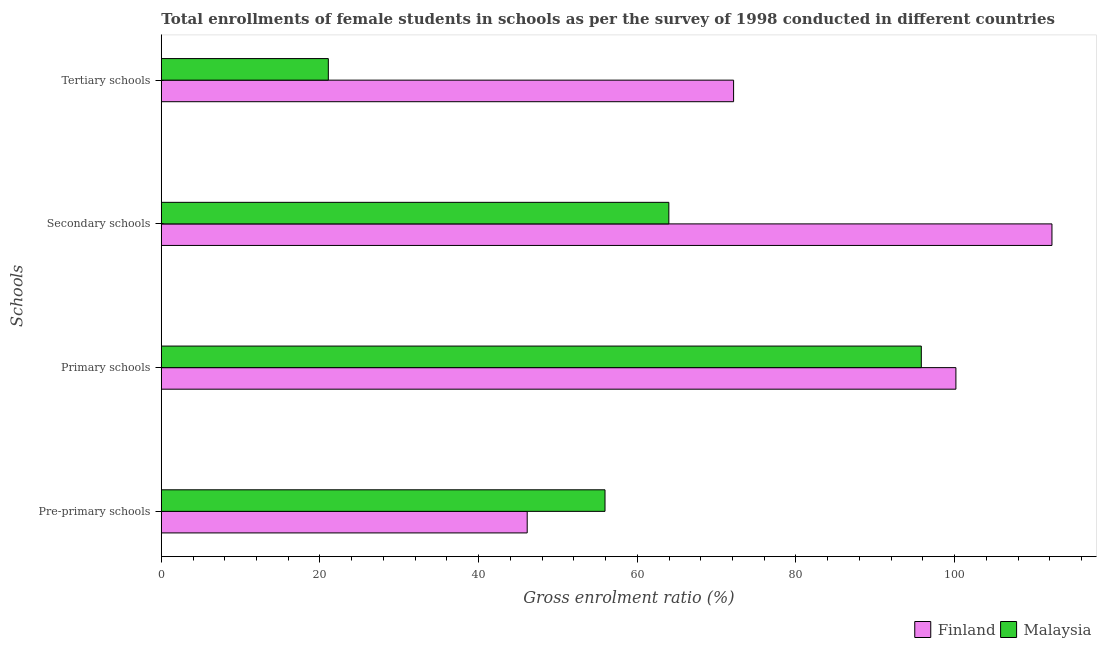How many different coloured bars are there?
Provide a short and direct response. 2. How many bars are there on the 3rd tick from the bottom?
Ensure brevity in your answer.  2. What is the label of the 1st group of bars from the top?
Make the answer very short. Tertiary schools. What is the gross enrolment ratio(female) in primary schools in Malaysia?
Your answer should be very brief. 95.8. Across all countries, what is the maximum gross enrolment ratio(female) in tertiary schools?
Make the answer very short. 72.14. Across all countries, what is the minimum gross enrolment ratio(female) in secondary schools?
Keep it short and to the point. 63.98. In which country was the gross enrolment ratio(female) in secondary schools maximum?
Make the answer very short. Finland. In which country was the gross enrolment ratio(female) in tertiary schools minimum?
Keep it short and to the point. Malaysia. What is the total gross enrolment ratio(female) in pre-primary schools in the graph?
Your answer should be compact. 102.05. What is the difference between the gross enrolment ratio(female) in tertiary schools in Finland and that in Malaysia?
Your answer should be very brief. 51.09. What is the difference between the gross enrolment ratio(female) in pre-primary schools in Finland and the gross enrolment ratio(female) in tertiary schools in Malaysia?
Your response must be concise. 25.07. What is the average gross enrolment ratio(female) in secondary schools per country?
Provide a succinct answer. 88.12. What is the difference between the gross enrolment ratio(female) in primary schools and gross enrolment ratio(female) in secondary schools in Finland?
Offer a terse response. -12.11. What is the ratio of the gross enrolment ratio(female) in tertiary schools in Malaysia to that in Finland?
Give a very brief answer. 0.29. Is the gross enrolment ratio(female) in secondary schools in Finland less than that in Malaysia?
Provide a succinct answer. No. Is the difference between the gross enrolment ratio(female) in pre-primary schools in Malaysia and Finland greater than the difference between the gross enrolment ratio(female) in primary schools in Malaysia and Finland?
Your response must be concise. Yes. What is the difference between the highest and the second highest gross enrolment ratio(female) in pre-primary schools?
Provide a short and direct response. 9.81. What is the difference between the highest and the lowest gross enrolment ratio(female) in secondary schools?
Your answer should be compact. 48.29. In how many countries, is the gross enrolment ratio(female) in tertiary schools greater than the average gross enrolment ratio(female) in tertiary schools taken over all countries?
Offer a very short reply. 1. What does the 2nd bar from the top in Secondary schools represents?
Offer a very short reply. Finland. What does the 1st bar from the bottom in Tertiary schools represents?
Your answer should be compact. Finland. Is it the case that in every country, the sum of the gross enrolment ratio(female) in pre-primary schools and gross enrolment ratio(female) in primary schools is greater than the gross enrolment ratio(female) in secondary schools?
Your response must be concise. Yes. How many bars are there?
Your answer should be compact. 8. What is the difference between two consecutive major ticks on the X-axis?
Provide a succinct answer. 20. Are the values on the major ticks of X-axis written in scientific E-notation?
Ensure brevity in your answer.  No. Where does the legend appear in the graph?
Offer a terse response. Bottom right. How many legend labels are there?
Keep it short and to the point. 2. How are the legend labels stacked?
Offer a terse response. Horizontal. What is the title of the graph?
Give a very brief answer. Total enrollments of female students in schools as per the survey of 1998 conducted in different countries. What is the label or title of the X-axis?
Your answer should be compact. Gross enrolment ratio (%). What is the label or title of the Y-axis?
Make the answer very short. Schools. What is the Gross enrolment ratio (%) of Finland in Pre-primary schools?
Provide a short and direct response. 46.12. What is the Gross enrolment ratio (%) of Malaysia in Pre-primary schools?
Your response must be concise. 55.93. What is the Gross enrolment ratio (%) of Finland in Primary schools?
Make the answer very short. 100.16. What is the Gross enrolment ratio (%) of Malaysia in Primary schools?
Your answer should be compact. 95.8. What is the Gross enrolment ratio (%) in Finland in Secondary schools?
Your response must be concise. 112.27. What is the Gross enrolment ratio (%) of Malaysia in Secondary schools?
Keep it short and to the point. 63.98. What is the Gross enrolment ratio (%) of Finland in Tertiary schools?
Keep it short and to the point. 72.14. What is the Gross enrolment ratio (%) in Malaysia in Tertiary schools?
Ensure brevity in your answer.  21.05. Across all Schools, what is the maximum Gross enrolment ratio (%) of Finland?
Offer a very short reply. 112.27. Across all Schools, what is the maximum Gross enrolment ratio (%) of Malaysia?
Provide a short and direct response. 95.8. Across all Schools, what is the minimum Gross enrolment ratio (%) in Finland?
Offer a very short reply. 46.12. Across all Schools, what is the minimum Gross enrolment ratio (%) in Malaysia?
Offer a terse response. 21.05. What is the total Gross enrolment ratio (%) in Finland in the graph?
Your response must be concise. 330.69. What is the total Gross enrolment ratio (%) in Malaysia in the graph?
Provide a short and direct response. 236.76. What is the difference between the Gross enrolment ratio (%) in Finland in Pre-primary schools and that in Primary schools?
Give a very brief answer. -54.04. What is the difference between the Gross enrolment ratio (%) in Malaysia in Pre-primary schools and that in Primary schools?
Keep it short and to the point. -39.87. What is the difference between the Gross enrolment ratio (%) of Finland in Pre-primary schools and that in Secondary schools?
Offer a very short reply. -66.15. What is the difference between the Gross enrolment ratio (%) in Malaysia in Pre-primary schools and that in Secondary schools?
Provide a succinct answer. -8.05. What is the difference between the Gross enrolment ratio (%) in Finland in Pre-primary schools and that in Tertiary schools?
Your answer should be compact. -26.02. What is the difference between the Gross enrolment ratio (%) in Malaysia in Pre-primary schools and that in Tertiary schools?
Your answer should be very brief. 34.88. What is the difference between the Gross enrolment ratio (%) of Finland in Primary schools and that in Secondary schools?
Offer a terse response. -12.11. What is the difference between the Gross enrolment ratio (%) in Malaysia in Primary schools and that in Secondary schools?
Ensure brevity in your answer.  31.82. What is the difference between the Gross enrolment ratio (%) of Finland in Primary schools and that in Tertiary schools?
Give a very brief answer. 28.02. What is the difference between the Gross enrolment ratio (%) in Malaysia in Primary schools and that in Tertiary schools?
Give a very brief answer. 74.75. What is the difference between the Gross enrolment ratio (%) of Finland in Secondary schools and that in Tertiary schools?
Offer a very short reply. 40.13. What is the difference between the Gross enrolment ratio (%) of Malaysia in Secondary schools and that in Tertiary schools?
Offer a very short reply. 42.92. What is the difference between the Gross enrolment ratio (%) in Finland in Pre-primary schools and the Gross enrolment ratio (%) in Malaysia in Primary schools?
Make the answer very short. -49.68. What is the difference between the Gross enrolment ratio (%) of Finland in Pre-primary schools and the Gross enrolment ratio (%) of Malaysia in Secondary schools?
Your response must be concise. -17.85. What is the difference between the Gross enrolment ratio (%) of Finland in Pre-primary schools and the Gross enrolment ratio (%) of Malaysia in Tertiary schools?
Offer a very short reply. 25.07. What is the difference between the Gross enrolment ratio (%) of Finland in Primary schools and the Gross enrolment ratio (%) of Malaysia in Secondary schools?
Ensure brevity in your answer.  36.18. What is the difference between the Gross enrolment ratio (%) of Finland in Primary schools and the Gross enrolment ratio (%) of Malaysia in Tertiary schools?
Provide a succinct answer. 79.11. What is the difference between the Gross enrolment ratio (%) in Finland in Secondary schools and the Gross enrolment ratio (%) in Malaysia in Tertiary schools?
Offer a very short reply. 91.22. What is the average Gross enrolment ratio (%) of Finland per Schools?
Your response must be concise. 82.67. What is the average Gross enrolment ratio (%) of Malaysia per Schools?
Ensure brevity in your answer.  59.19. What is the difference between the Gross enrolment ratio (%) of Finland and Gross enrolment ratio (%) of Malaysia in Pre-primary schools?
Your answer should be very brief. -9.81. What is the difference between the Gross enrolment ratio (%) in Finland and Gross enrolment ratio (%) in Malaysia in Primary schools?
Ensure brevity in your answer.  4.36. What is the difference between the Gross enrolment ratio (%) of Finland and Gross enrolment ratio (%) of Malaysia in Secondary schools?
Your answer should be very brief. 48.29. What is the difference between the Gross enrolment ratio (%) of Finland and Gross enrolment ratio (%) of Malaysia in Tertiary schools?
Make the answer very short. 51.09. What is the ratio of the Gross enrolment ratio (%) in Finland in Pre-primary schools to that in Primary schools?
Your response must be concise. 0.46. What is the ratio of the Gross enrolment ratio (%) of Malaysia in Pre-primary schools to that in Primary schools?
Offer a very short reply. 0.58. What is the ratio of the Gross enrolment ratio (%) in Finland in Pre-primary schools to that in Secondary schools?
Your answer should be compact. 0.41. What is the ratio of the Gross enrolment ratio (%) of Malaysia in Pre-primary schools to that in Secondary schools?
Provide a succinct answer. 0.87. What is the ratio of the Gross enrolment ratio (%) of Finland in Pre-primary schools to that in Tertiary schools?
Your answer should be compact. 0.64. What is the ratio of the Gross enrolment ratio (%) in Malaysia in Pre-primary schools to that in Tertiary schools?
Give a very brief answer. 2.66. What is the ratio of the Gross enrolment ratio (%) in Finland in Primary schools to that in Secondary schools?
Keep it short and to the point. 0.89. What is the ratio of the Gross enrolment ratio (%) in Malaysia in Primary schools to that in Secondary schools?
Provide a short and direct response. 1.5. What is the ratio of the Gross enrolment ratio (%) in Finland in Primary schools to that in Tertiary schools?
Make the answer very short. 1.39. What is the ratio of the Gross enrolment ratio (%) of Malaysia in Primary schools to that in Tertiary schools?
Ensure brevity in your answer.  4.55. What is the ratio of the Gross enrolment ratio (%) in Finland in Secondary schools to that in Tertiary schools?
Ensure brevity in your answer.  1.56. What is the ratio of the Gross enrolment ratio (%) in Malaysia in Secondary schools to that in Tertiary schools?
Your answer should be very brief. 3.04. What is the difference between the highest and the second highest Gross enrolment ratio (%) in Finland?
Give a very brief answer. 12.11. What is the difference between the highest and the second highest Gross enrolment ratio (%) of Malaysia?
Give a very brief answer. 31.82. What is the difference between the highest and the lowest Gross enrolment ratio (%) in Finland?
Give a very brief answer. 66.15. What is the difference between the highest and the lowest Gross enrolment ratio (%) in Malaysia?
Offer a very short reply. 74.75. 